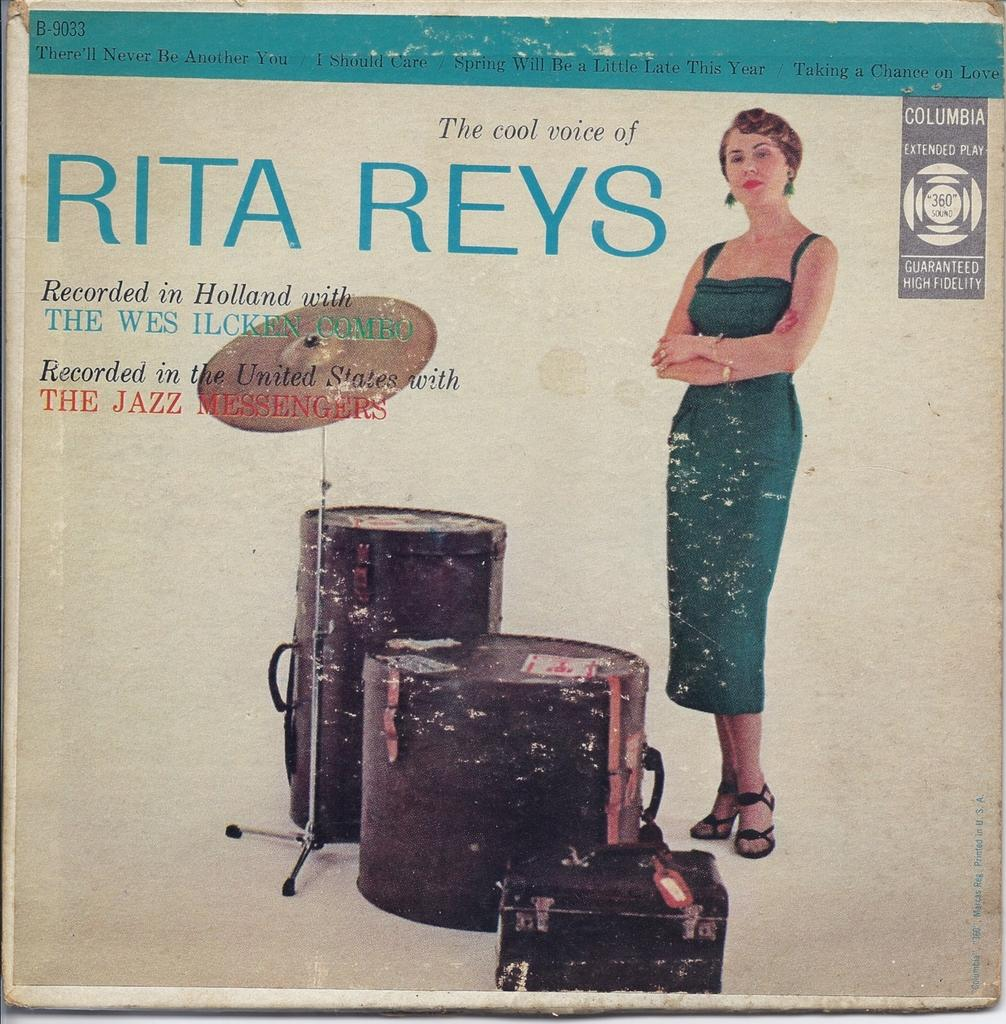What is the purpose of the image? The image is for a poster. Who is present in the image? There is a woman standing in the image. What else can be seen in the image besides the woman? There are musical instruments in the image. What is written at the top of the image? There is text at the top of the image. What type of level is being used by the woman in the image? There is no level present in the image, and the woman is not using any tools. What is the texture of the musical instruments in the image? The texture of the musical instruments cannot be determined from the image alone, as it only provides visual information. 